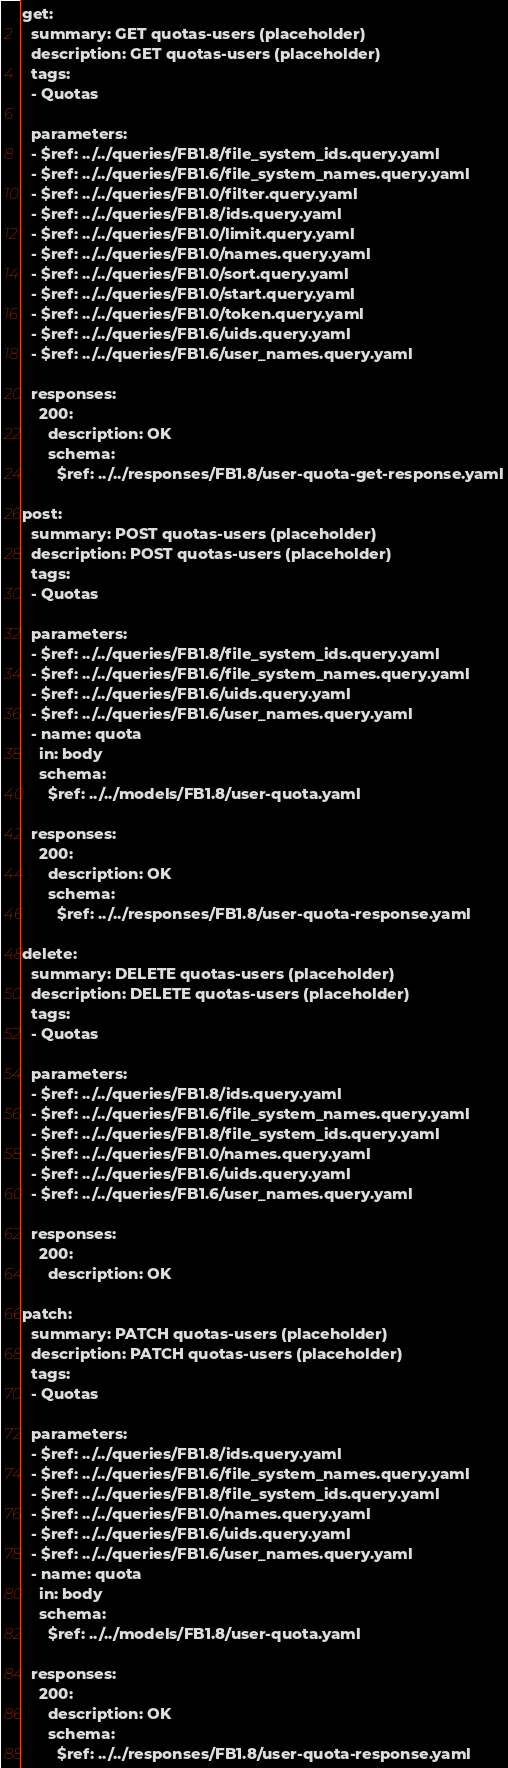Convert code to text. <code><loc_0><loc_0><loc_500><loc_500><_YAML_>get:
  summary: GET quotas-users (placeholder)
  description: GET quotas-users (placeholder)
  tags:
  - Quotas

  parameters:
  - $ref: ../../queries/FB1.8/file_system_ids.query.yaml
  - $ref: ../../queries/FB1.6/file_system_names.query.yaml
  - $ref: ../../queries/FB1.0/filter.query.yaml
  - $ref: ../../queries/FB1.8/ids.query.yaml
  - $ref: ../../queries/FB1.0/limit.query.yaml
  - $ref: ../../queries/FB1.0/names.query.yaml
  - $ref: ../../queries/FB1.0/sort.query.yaml
  - $ref: ../../queries/FB1.0/start.query.yaml
  - $ref: ../../queries/FB1.0/token.query.yaml
  - $ref: ../../queries/FB1.6/uids.query.yaml
  - $ref: ../../queries/FB1.6/user_names.query.yaml

  responses:
    200:
      description: OK
      schema:
        $ref: ../../responses/FB1.8/user-quota-get-response.yaml

post:
  summary: POST quotas-users (placeholder)
  description: POST quotas-users (placeholder)
  tags:
  - Quotas

  parameters:
  - $ref: ../../queries/FB1.8/file_system_ids.query.yaml
  - $ref: ../../queries/FB1.6/file_system_names.query.yaml
  - $ref: ../../queries/FB1.6/uids.query.yaml
  - $ref: ../../queries/FB1.6/user_names.query.yaml
  - name: quota
    in: body
    schema:
      $ref: ../../models/FB1.8/user-quota.yaml

  responses:
    200:
      description: OK
      schema:
        $ref: ../../responses/FB1.8/user-quota-response.yaml

delete:
  summary: DELETE quotas-users (placeholder)
  description: DELETE quotas-users (placeholder)
  tags:
  - Quotas

  parameters:
  - $ref: ../../queries/FB1.8/ids.query.yaml
  - $ref: ../../queries/FB1.6/file_system_names.query.yaml
  - $ref: ../../queries/FB1.8/file_system_ids.query.yaml
  - $ref: ../../queries/FB1.0/names.query.yaml
  - $ref: ../../queries/FB1.6/uids.query.yaml
  - $ref: ../../queries/FB1.6/user_names.query.yaml

  responses:
    200:
      description: OK

patch:
  summary: PATCH quotas-users (placeholder)
  description: PATCH quotas-users (placeholder)
  tags:
  - Quotas

  parameters:
  - $ref: ../../queries/FB1.8/ids.query.yaml
  - $ref: ../../queries/FB1.6/file_system_names.query.yaml
  - $ref: ../../queries/FB1.8/file_system_ids.query.yaml
  - $ref: ../../queries/FB1.0/names.query.yaml
  - $ref: ../../queries/FB1.6/uids.query.yaml
  - $ref: ../../queries/FB1.6/user_names.query.yaml
  - name: quota
    in: body
    schema:
      $ref: ../../models/FB1.8/user-quota.yaml

  responses:
    200:
      description: OK
      schema:
        $ref: ../../responses/FB1.8/user-quota-response.yaml
</code> 